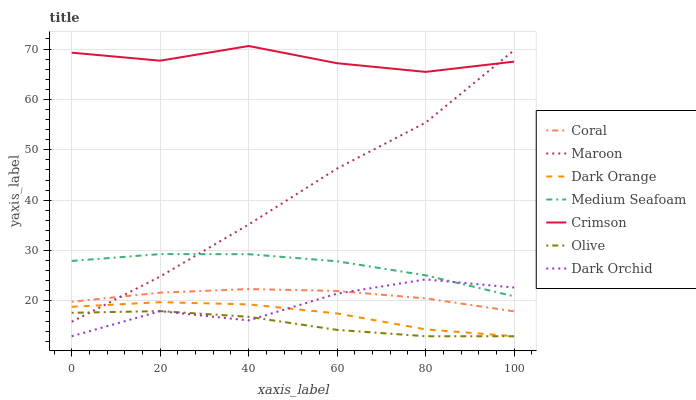Does Olive have the minimum area under the curve?
Answer yes or no. Yes. Does Crimson have the maximum area under the curve?
Answer yes or no. Yes. Does Coral have the minimum area under the curve?
Answer yes or no. No. Does Coral have the maximum area under the curve?
Answer yes or no. No. Is Coral the smoothest?
Answer yes or no. Yes. Is Dark Orchid the roughest?
Answer yes or no. Yes. Is Maroon the smoothest?
Answer yes or no. No. Is Maroon the roughest?
Answer yes or no. No. Does Dark Orange have the lowest value?
Answer yes or no. Yes. Does Coral have the lowest value?
Answer yes or no. No. Does Crimson have the highest value?
Answer yes or no. Yes. Does Coral have the highest value?
Answer yes or no. No. Is Dark Orchid less than Maroon?
Answer yes or no. Yes. Is Medium Seafoam greater than Coral?
Answer yes or no. Yes. Does Dark Orange intersect Olive?
Answer yes or no. Yes. Is Dark Orange less than Olive?
Answer yes or no. No. Is Dark Orange greater than Olive?
Answer yes or no. No. Does Dark Orchid intersect Maroon?
Answer yes or no. No. 